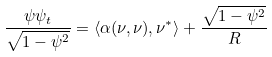Convert formula to latex. <formula><loc_0><loc_0><loc_500><loc_500>\frac { \psi \psi _ { t } } { \sqrt { 1 - \psi ^ { 2 } } } = \langle \alpha ( \nu , \nu ) , \nu ^ { * } \rangle + \frac { \sqrt { 1 - \psi ^ { 2 } } } { R }</formula> 